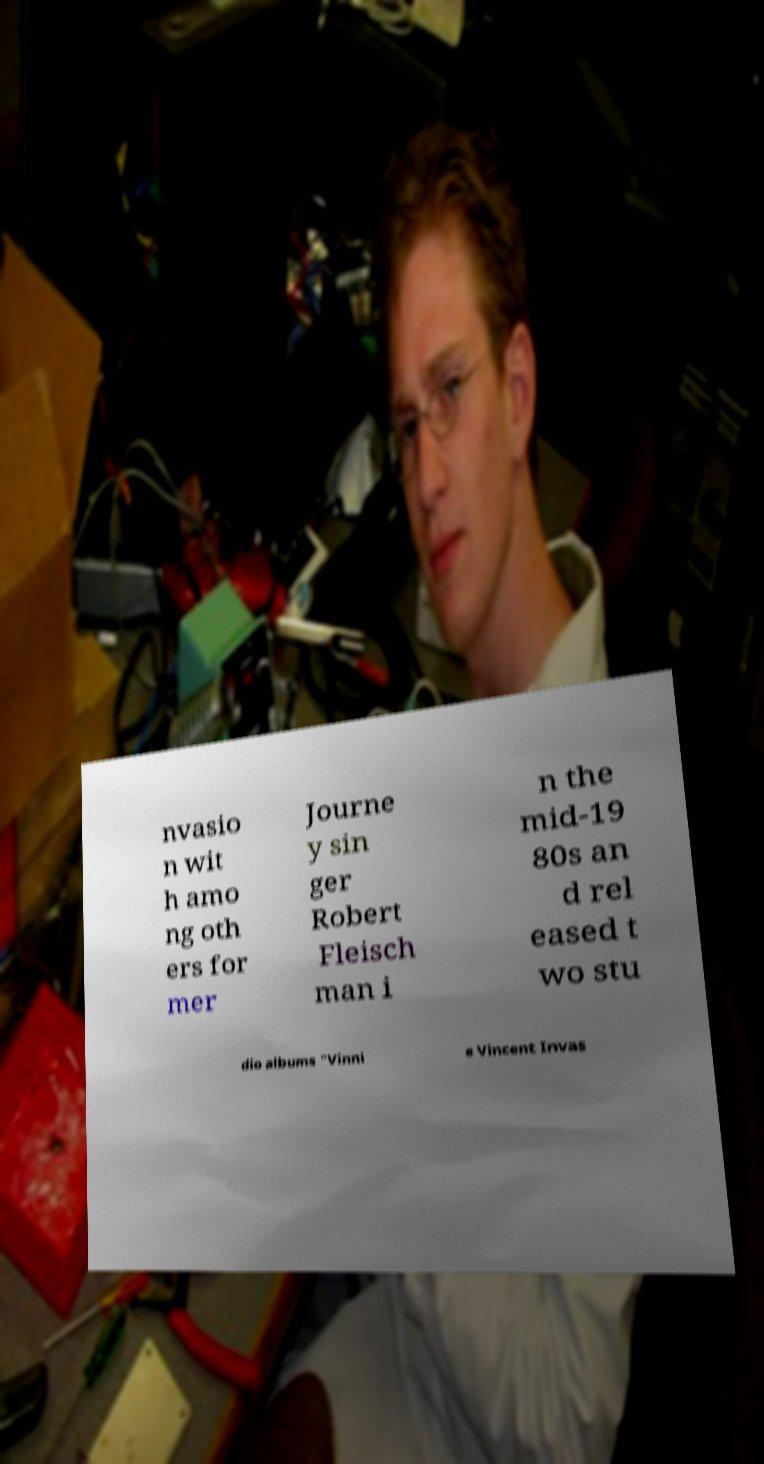I need the written content from this picture converted into text. Can you do that? nvasio n wit h amo ng oth ers for mer Journe y sin ger Robert Fleisch man i n the mid-19 80s an d rel eased t wo stu dio albums "Vinni e Vincent Invas 